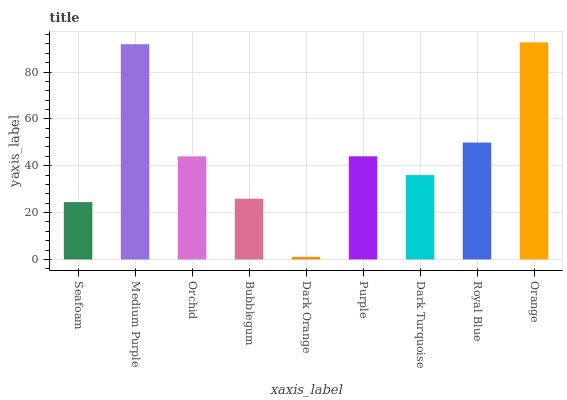Is Medium Purple the minimum?
Answer yes or no. No. Is Medium Purple the maximum?
Answer yes or no. No. Is Medium Purple greater than Seafoam?
Answer yes or no. Yes. Is Seafoam less than Medium Purple?
Answer yes or no. Yes. Is Seafoam greater than Medium Purple?
Answer yes or no. No. Is Medium Purple less than Seafoam?
Answer yes or no. No. Is Orchid the high median?
Answer yes or no. Yes. Is Orchid the low median?
Answer yes or no. Yes. Is Bubblegum the high median?
Answer yes or no. No. Is Dark Orange the low median?
Answer yes or no. No. 